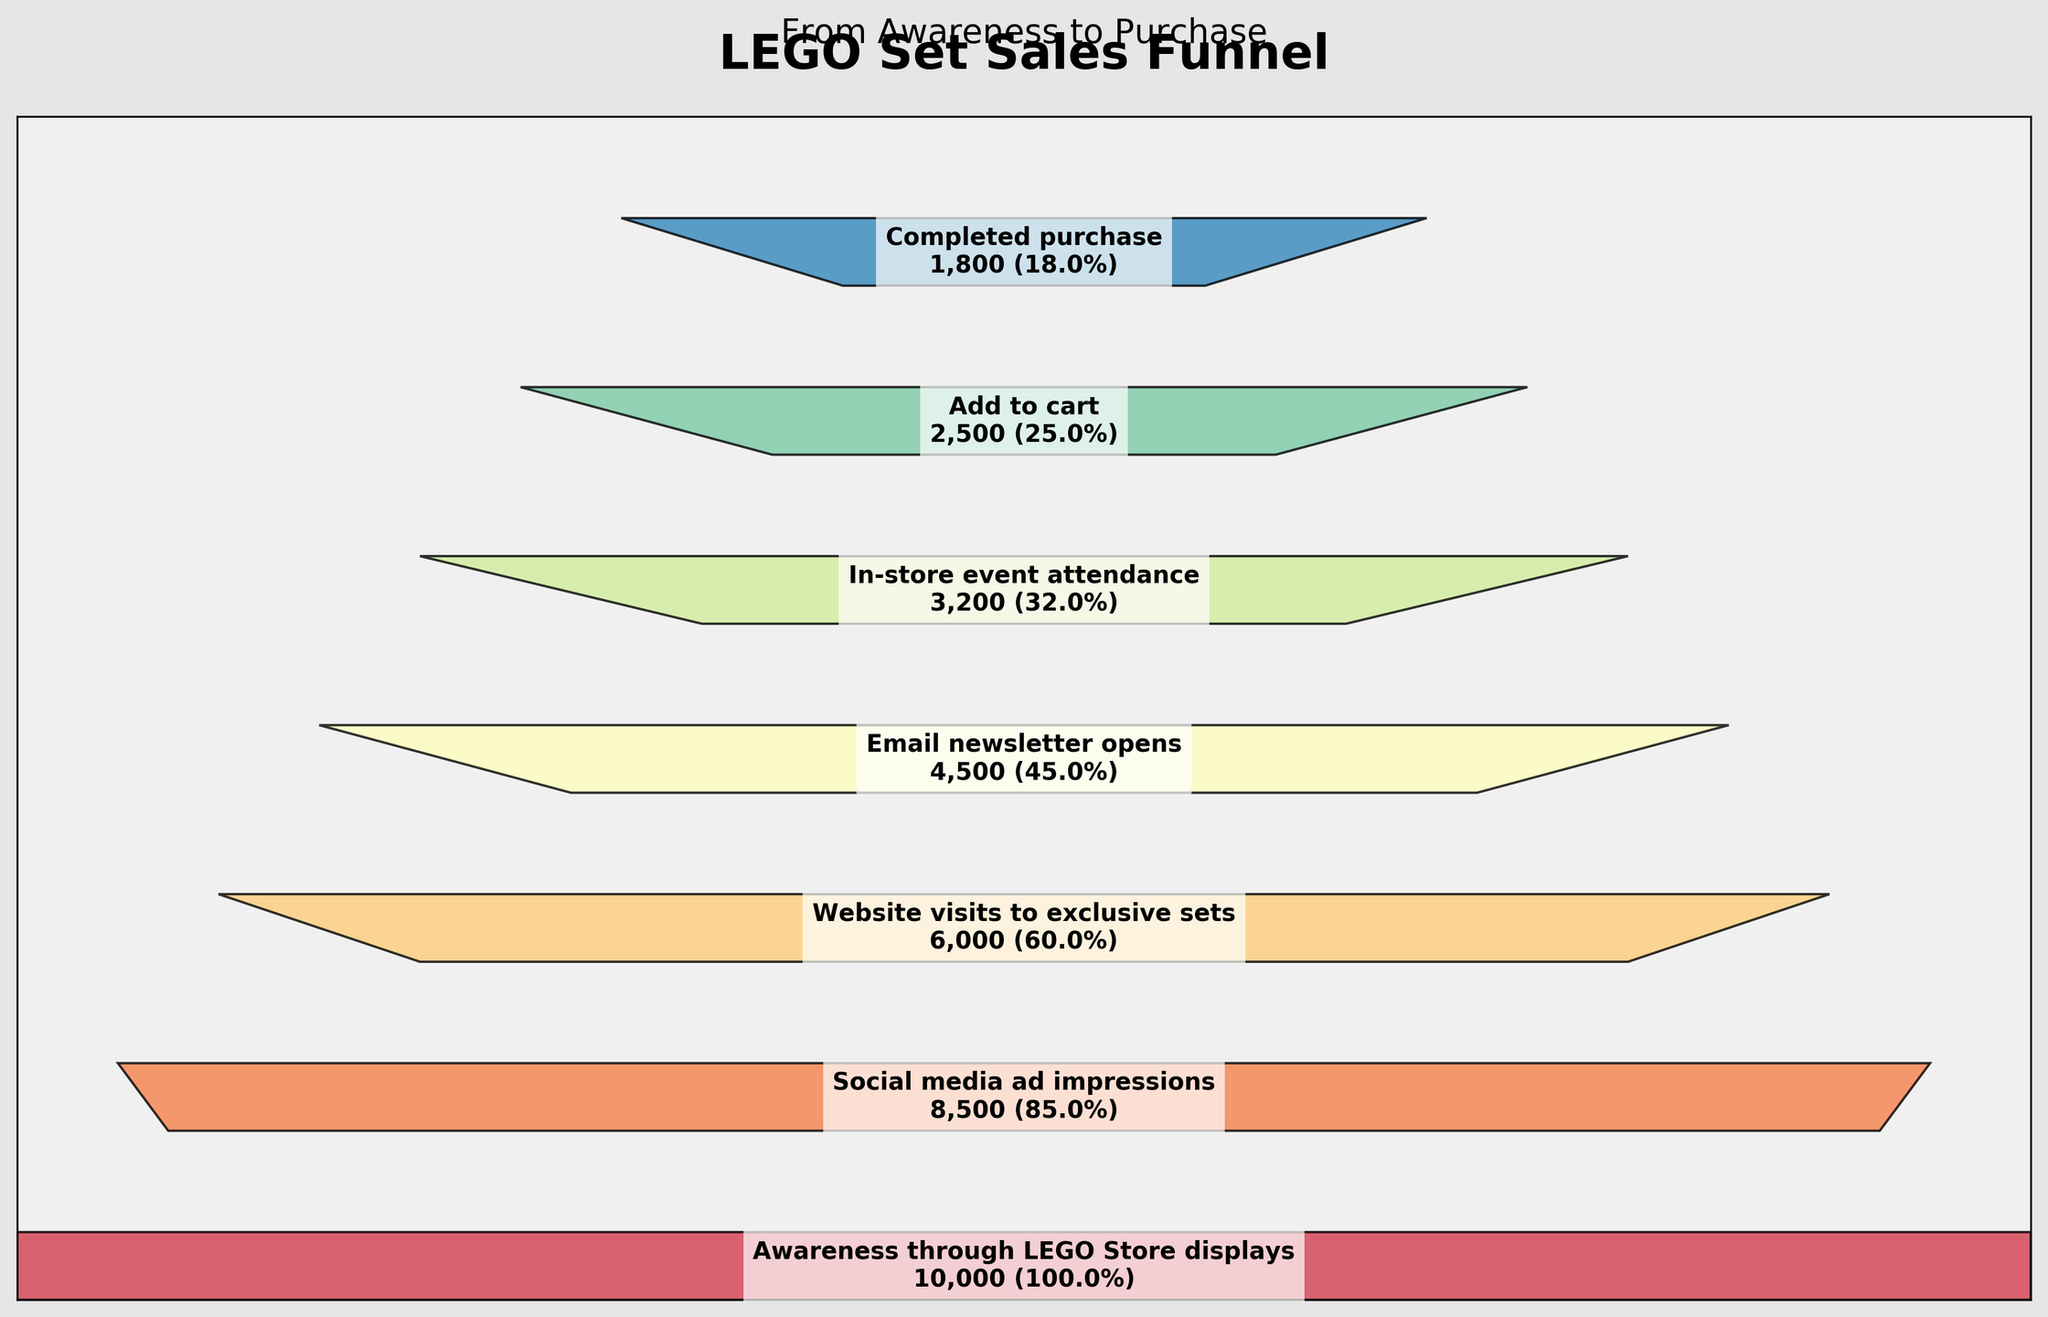what is the title of the funnel chart? The title of the funnel chart is displayed at the top of the figure, which reads "LEGO Set Sales Funnel".
Answer: LEGO Set Sales Funnel How many stages are illustrated in the funnel chart? The funnel chart illustrates various stages, from "Awareness through LEGO Store displays" to "Completed purchase". By counting these, we see there are 7 stages in total.
Answer: 7 At which stage does the highest drop in count occur? To identify the stage with the highest drop, compare the count between consecutive stages. The drop from "Awareness through LEGO Store displays" (10,000) to "Social media ad impressions" (8,500) is 1,500, which is the highest drop.
Answer: From "Awareness through LEGO Store displays" to "Social media ad impressions" What percentage of people who attended in-store events added items to their cart? Look at the figures for "In-store event attendance" (3,200) and "Add to cart" (2,500). The percentage is calculated as (2500 / 3200) * 100 = 78.1%.
Answer: 78.1% Compare the number of website visits to exclusive sets to the number of completed purchases. How fewer purchases were completed? The number of website visits to exclusive sets is 6,000, while the number of completed purchases is 1,800. The difference is 6000 - 1800 = 4200.
Answer: 4,200 What stage directly follows the stage of "Email newsletter opens"? Looking at the funnel chart, the stage that comes after "Email newsletter opens" is "In-store event attendance".
Answer: In-store event attendance Is the percentage of "Add to cart" stage higher or lower than the percentage of "Website visits to exclusive sets" stage? The chart indicates the percentage for "Add to cart" is (2,500 / 10,000) * 100 = 25%, and for "Website visits to exclusive sets" is (6,000 / 10,000) * 100 = 60%. Hence, the "Add to cart" stage percentage is lower.
Answer: Lower What is the trend observed as we move from Awareness through LEGO Store displays to Completed purchase? As we move down each stage in the funnel, the count consistently decreases, indicating a drop-off in the number of participants at each subsequent stage.
Answer: Decreasing trend Calculate the average number of participants across all stages. Sum up all the counts (10,000 + 8,500 + 6,000 + 4,500 + 3,200 + 2,500 + 1,800) and divide by the number of stages (7). So, the average is (36,500 / 7) = 5,214.29.
Answer: 5,214.29 What stage has the lowest percentage of participants relative to the initial stage? Looking at the percentages, the stage "Completed purchase" has the count of 1,800, which is 18% of the initial stage (10,000). No other stage has a lower percentage.
Answer: Completed purchase 